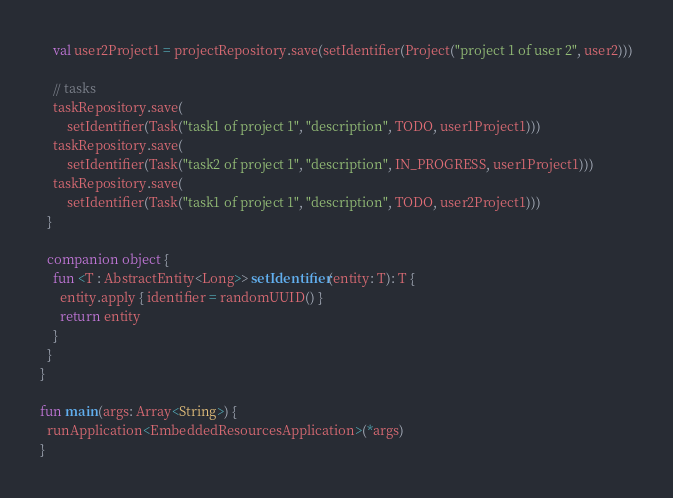<code> <loc_0><loc_0><loc_500><loc_500><_Kotlin_>    val user2Project1 = projectRepository.save(setIdentifier(Project("project 1 of user 2", user2)))

    // tasks
    taskRepository.save(
        setIdentifier(Task("task1 of project 1", "description", TODO, user1Project1)))
    taskRepository.save(
        setIdentifier(Task("task2 of project 1", "description", IN_PROGRESS, user1Project1)))
    taskRepository.save(
        setIdentifier(Task("task1 of project 1", "description", TODO, user2Project1)))
  }

  companion object {
    fun <T : AbstractEntity<Long>> setIdentifier(entity: T): T {
      entity.apply { identifier = randomUUID() }
      return entity
    }
  }
}

fun main(args: Array<String>) {
  runApplication<EmbeddedResourcesApplication>(*args)
}
</code> 